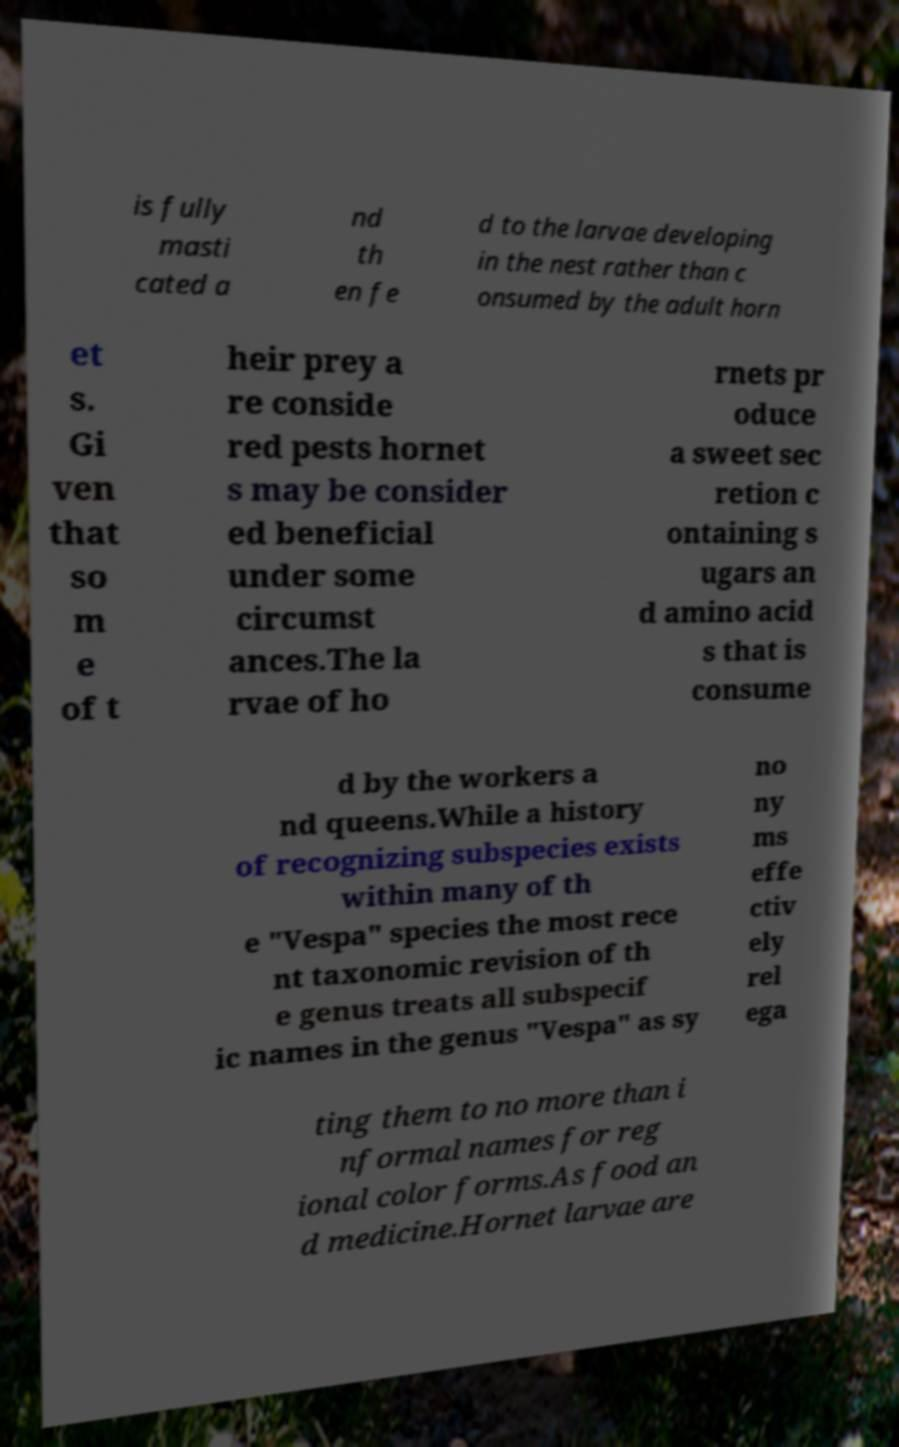Could you assist in decoding the text presented in this image and type it out clearly? is fully masti cated a nd th en fe d to the larvae developing in the nest rather than c onsumed by the adult horn et s. Gi ven that so m e of t heir prey a re conside red pests hornet s may be consider ed beneficial under some circumst ances.The la rvae of ho rnets pr oduce a sweet sec retion c ontaining s ugars an d amino acid s that is consume d by the workers a nd queens.While a history of recognizing subspecies exists within many of th e "Vespa" species the most rece nt taxonomic revision of th e genus treats all subspecif ic names in the genus "Vespa" as sy no ny ms effe ctiv ely rel ega ting them to no more than i nformal names for reg ional color forms.As food an d medicine.Hornet larvae are 